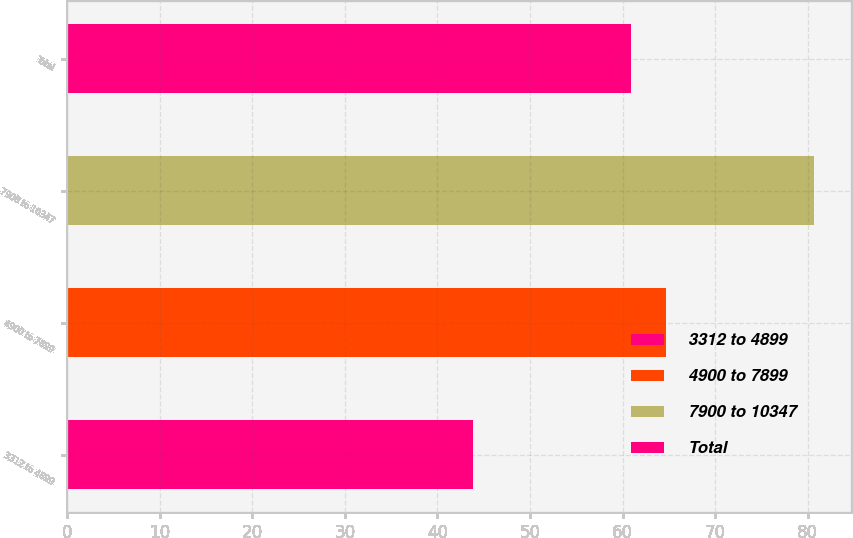Convert chart to OTSL. <chart><loc_0><loc_0><loc_500><loc_500><bar_chart><fcel>3312 to 4899<fcel>4900 to 7899<fcel>7900 to 10347<fcel>Total<nl><fcel>43.88<fcel>64.68<fcel>80.63<fcel>60.88<nl></chart> 